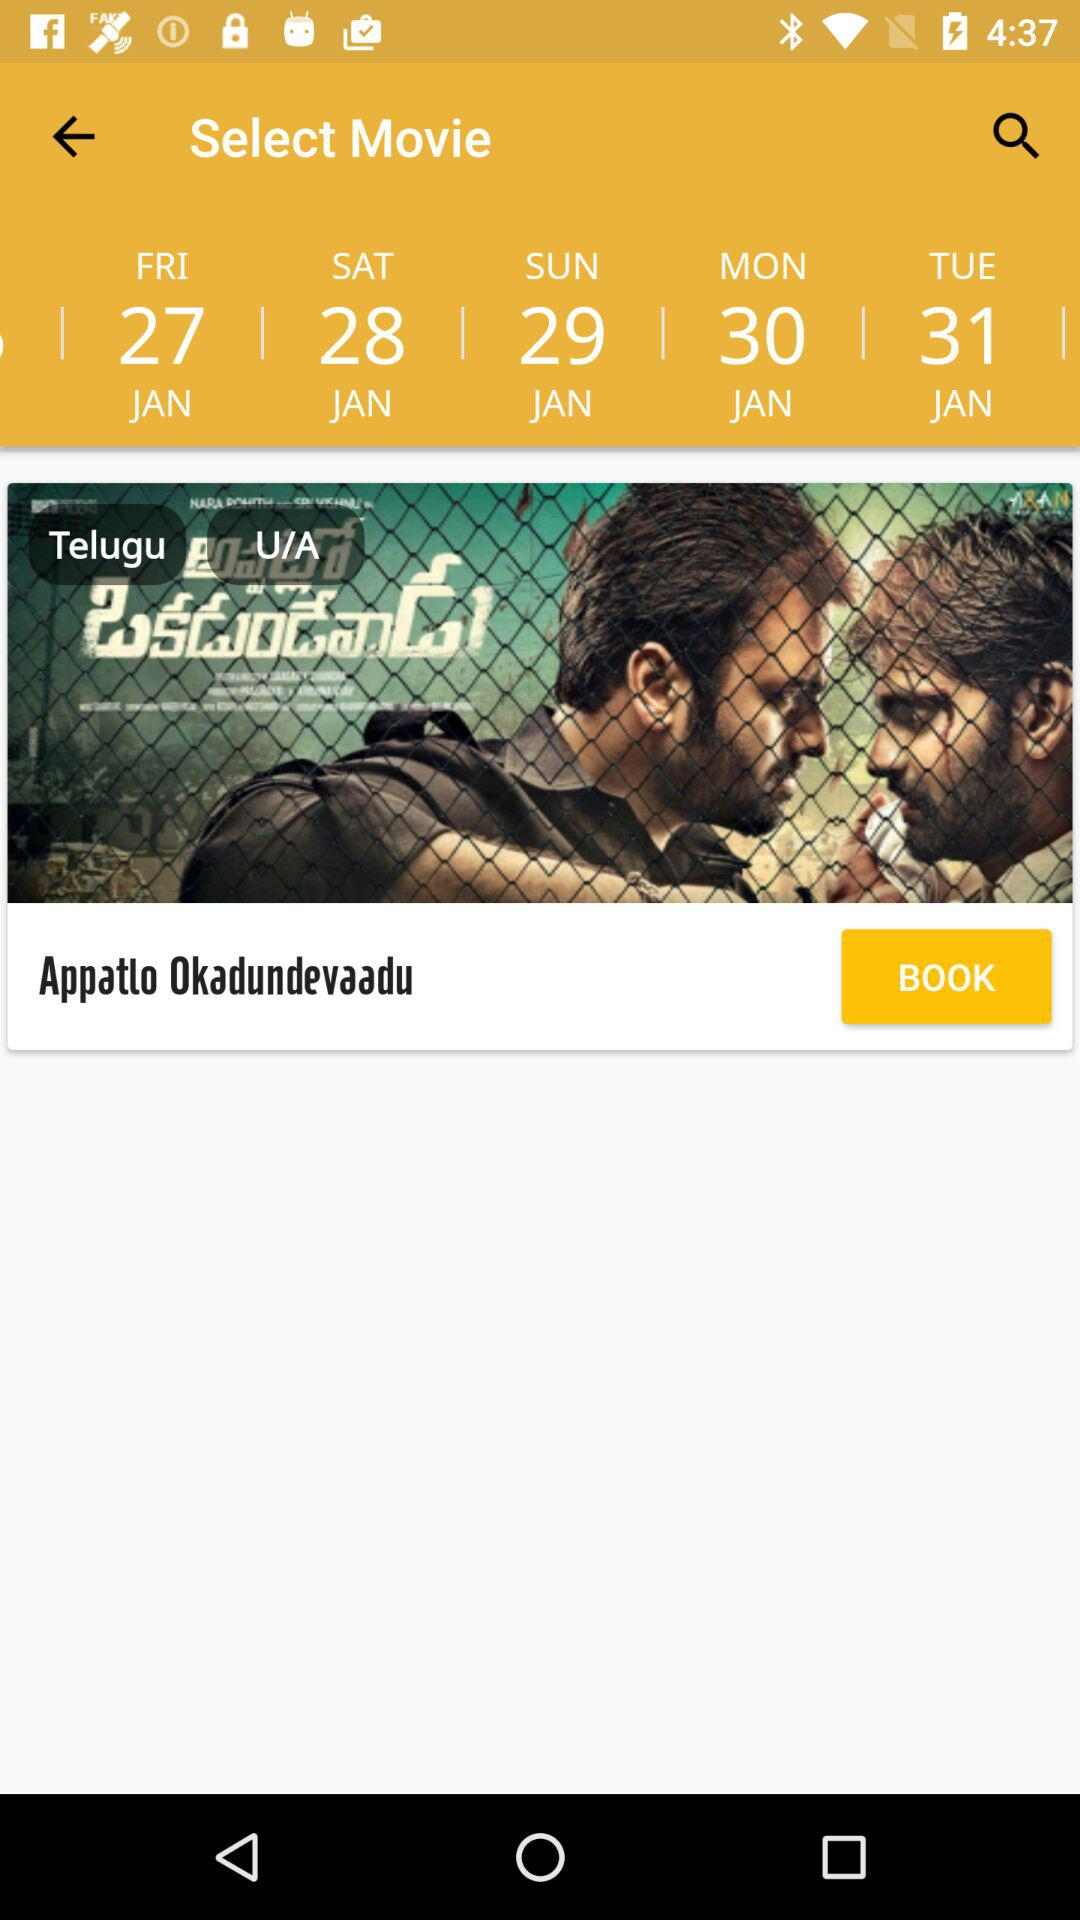What's the day on the 28th of January? The day on the 28th of January is Saturday. 